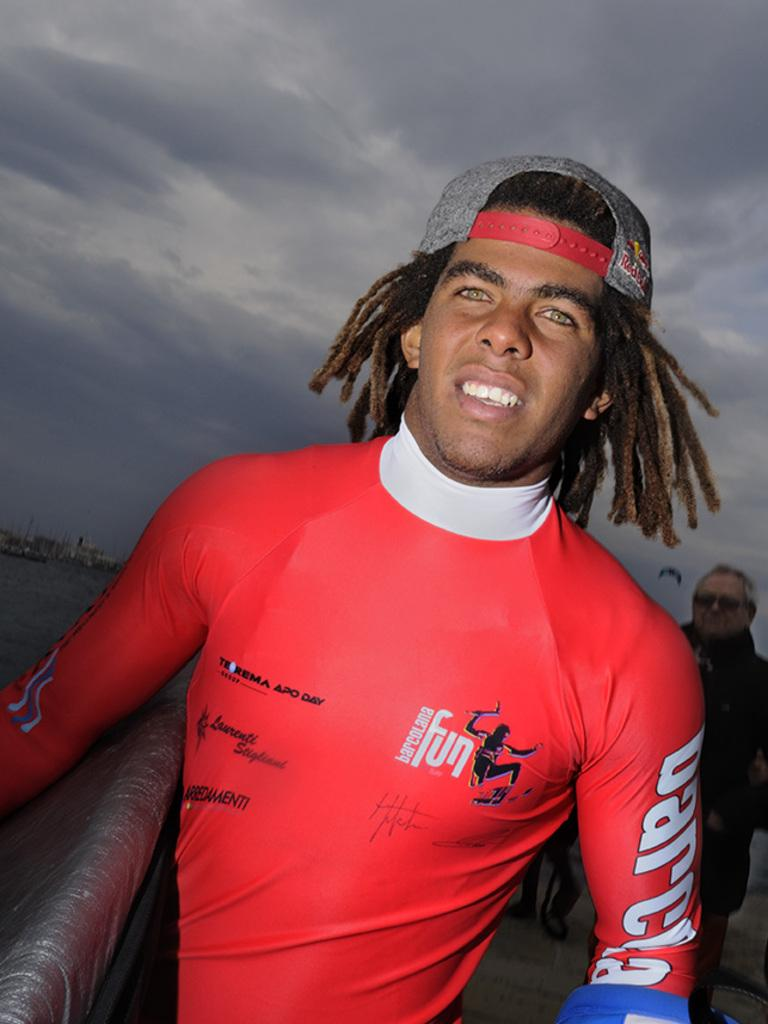<image>
Summarize the visual content of the image. A man with a hat wearing a red shirt starting barcelona fun on it.. 